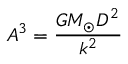Convert formula to latex. <formula><loc_0><loc_0><loc_500><loc_500>A ^ { 3 } = { \frac { G M _ { \odot } D ^ { 2 } } { k ^ { 2 } } }</formula> 